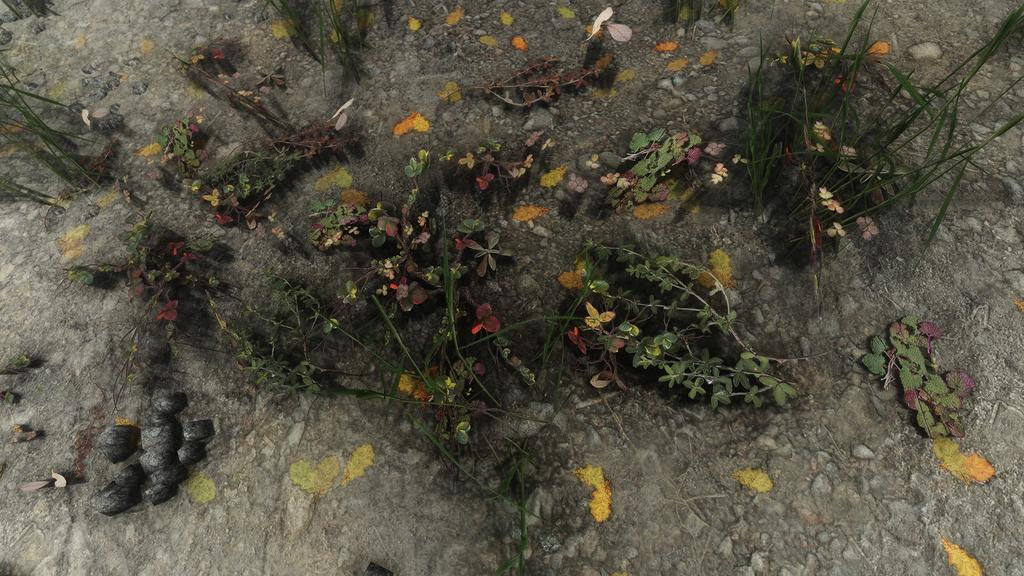What type of living organisms can be seen in the image? Plants can be seen in the image. What part of the plants is visible in the image? Leaves are visible in the image. What type of inanimate objects can be seen in the image? Stones are present in the image. Where is the basket located in the image? There is no basket present in the image. Can you see any chickens in the image? There are no chickens present in the image. 